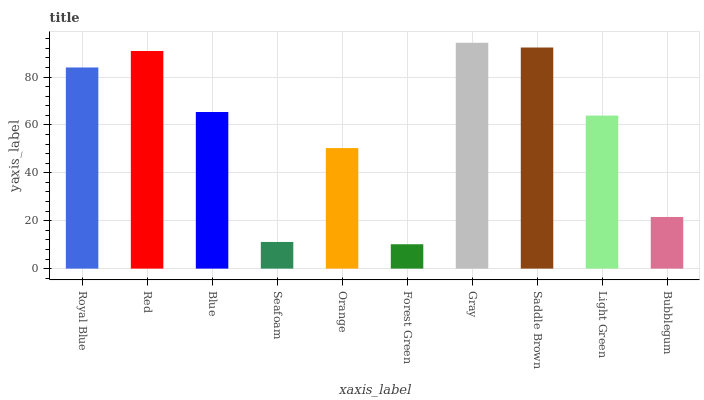Is Forest Green the minimum?
Answer yes or no. Yes. Is Gray the maximum?
Answer yes or no. Yes. Is Red the minimum?
Answer yes or no. No. Is Red the maximum?
Answer yes or no. No. Is Red greater than Royal Blue?
Answer yes or no. Yes. Is Royal Blue less than Red?
Answer yes or no. Yes. Is Royal Blue greater than Red?
Answer yes or no. No. Is Red less than Royal Blue?
Answer yes or no. No. Is Blue the high median?
Answer yes or no. Yes. Is Light Green the low median?
Answer yes or no. Yes. Is Saddle Brown the high median?
Answer yes or no. No. Is Forest Green the low median?
Answer yes or no. No. 